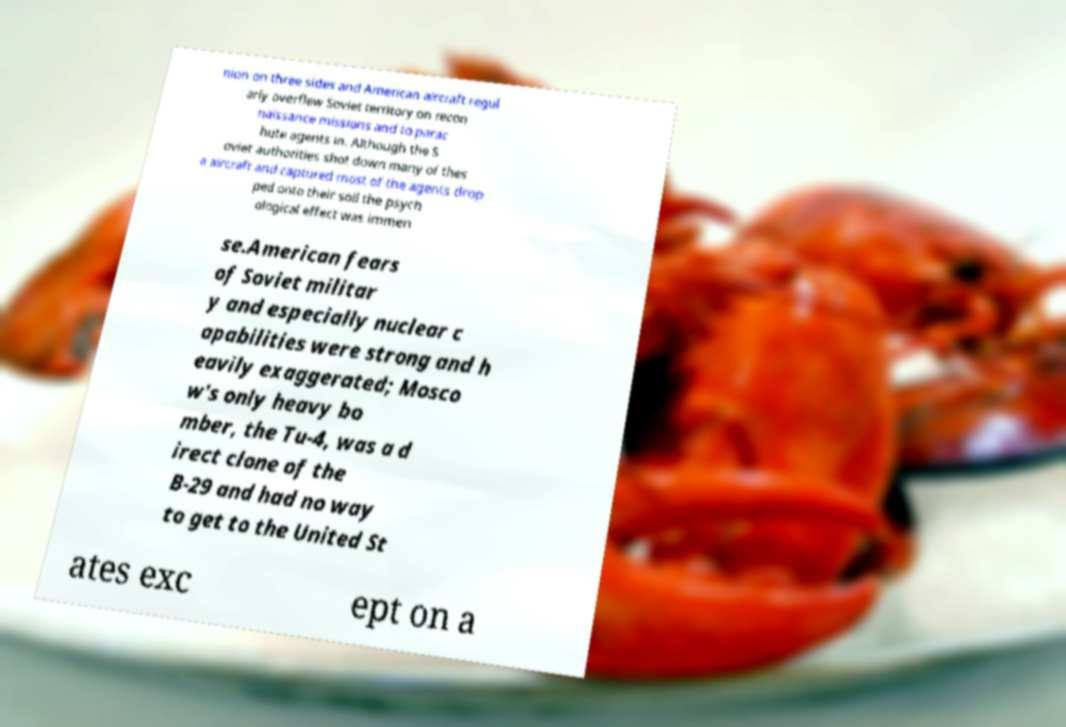Can you read and provide the text displayed in the image?This photo seems to have some interesting text. Can you extract and type it out for me? nion on three sides and American aircraft regul arly overflew Soviet territory on recon naissance missions and to parac hute agents in. Although the S oviet authorities shot down many of thes e aircraft and captured most of the agents drop ped onto their soil the psych ological effect was immen se.American fears of Soviet militar y and especially nuclear c apabilities were strong and h eavily exaggerated; Mosco w's only heavy bo mber, the Tu-4, was a d irect clone of the B-29 and had no way to get to the United St ates exc ept on a 